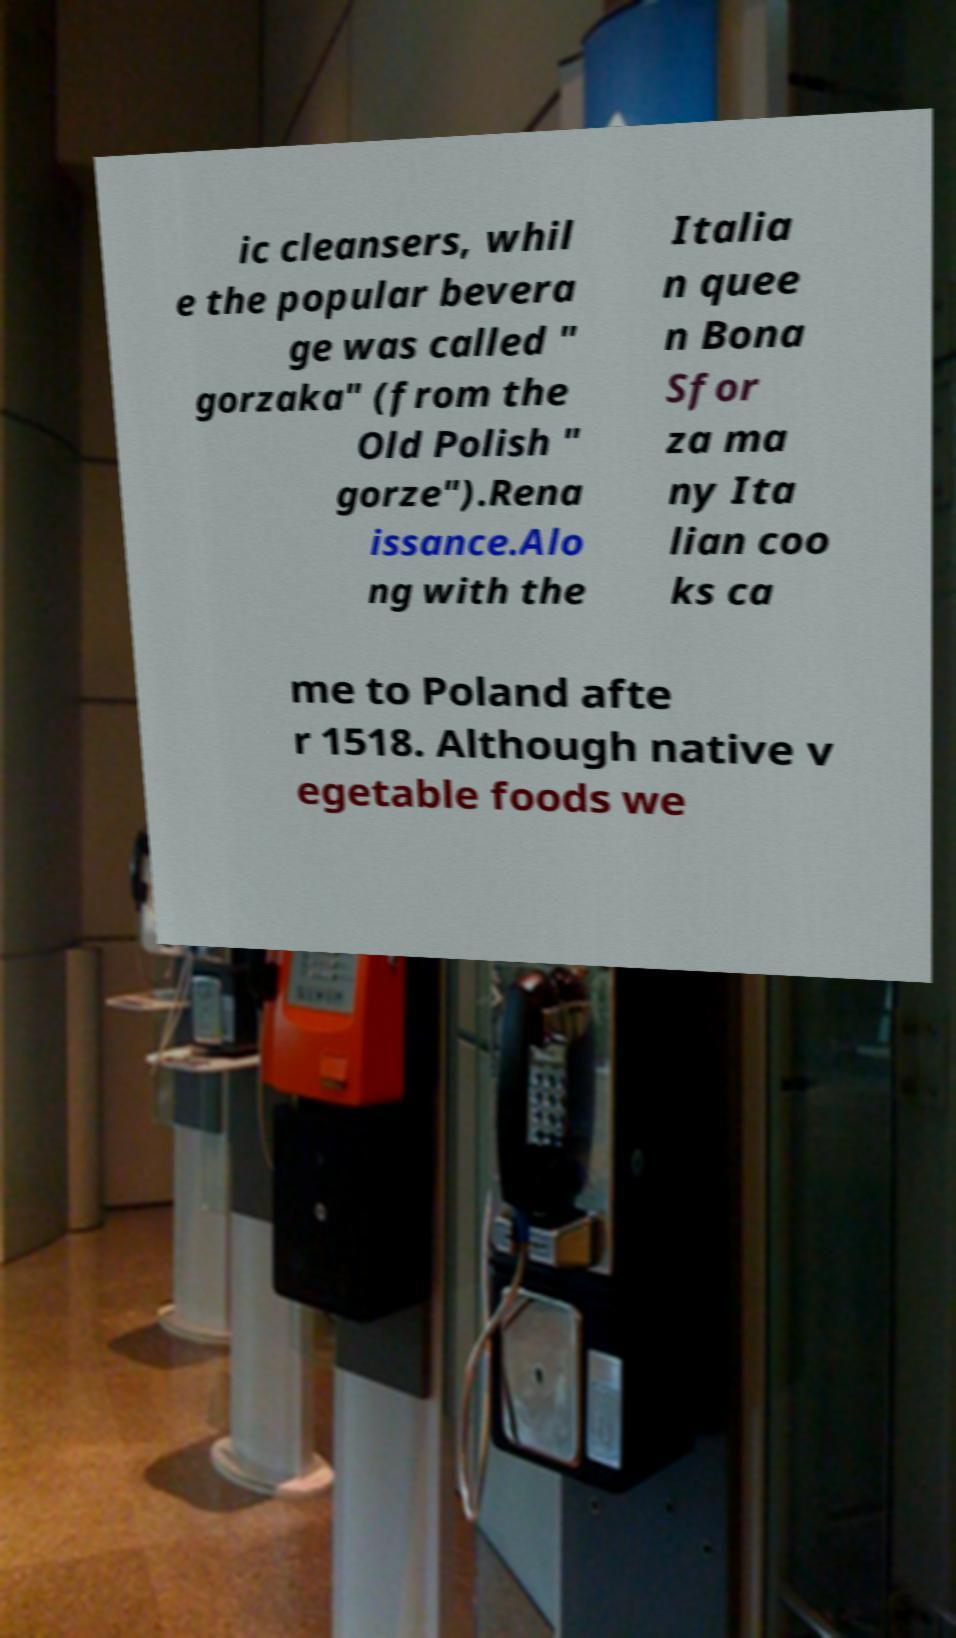I need the written content from this picture converted into text. Can you do that? ic cleansers, whil e the popular bevera ge was called " gorzaka" (from the Old Polish " gorze").Rena issance.Alo ng with the Italia n quee n Bona Sfor za ma ny Ita lian coo ks ca me to Poland afte r 1518. Although native v egetable foods we 